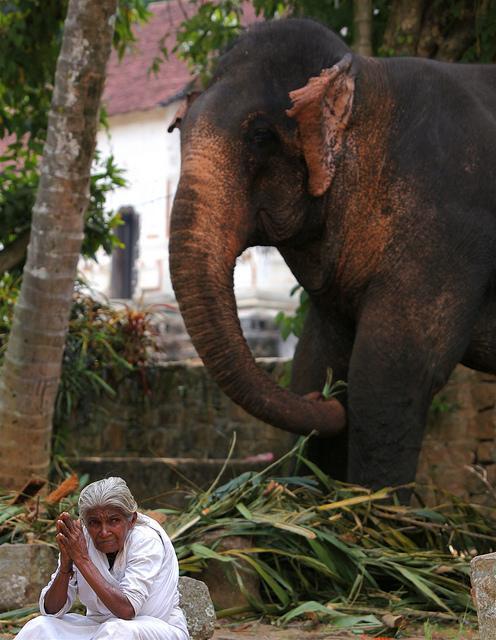How many signs have bus icon on a pole?
Give a very brief answer. 0. 